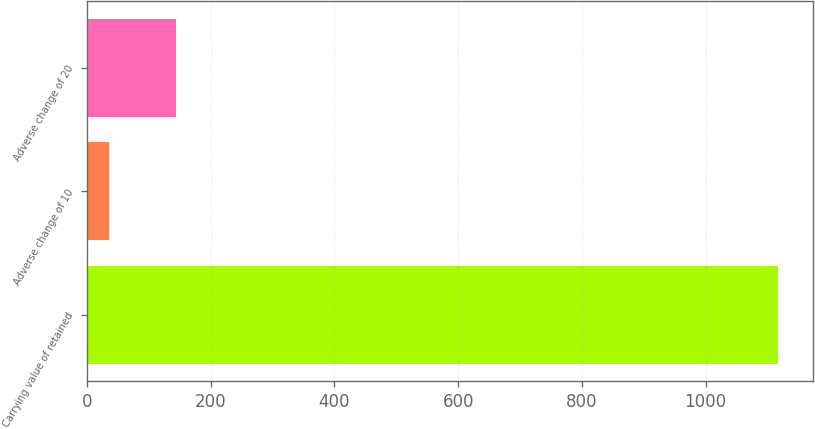Convert chart to OTSL. <chart><loc_0><loc_0><loc_500><loc_500><bar_chart><fcel>Carrying value of retained<fcel>Adverse change of 10<fcel>Adverse change of 20<nl><fcel>1118<fcel>35<fcel>143.3<nl></chart> 